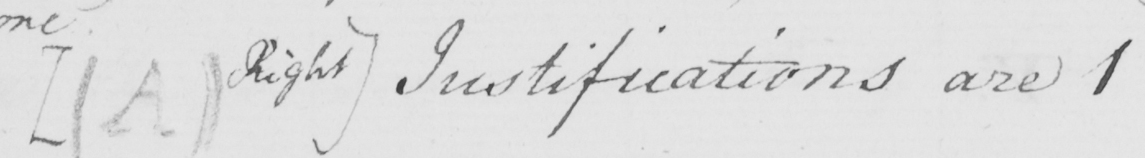Please provide the text content of this handwritten line. [  ( A )  Right ]  Justifications are 1 